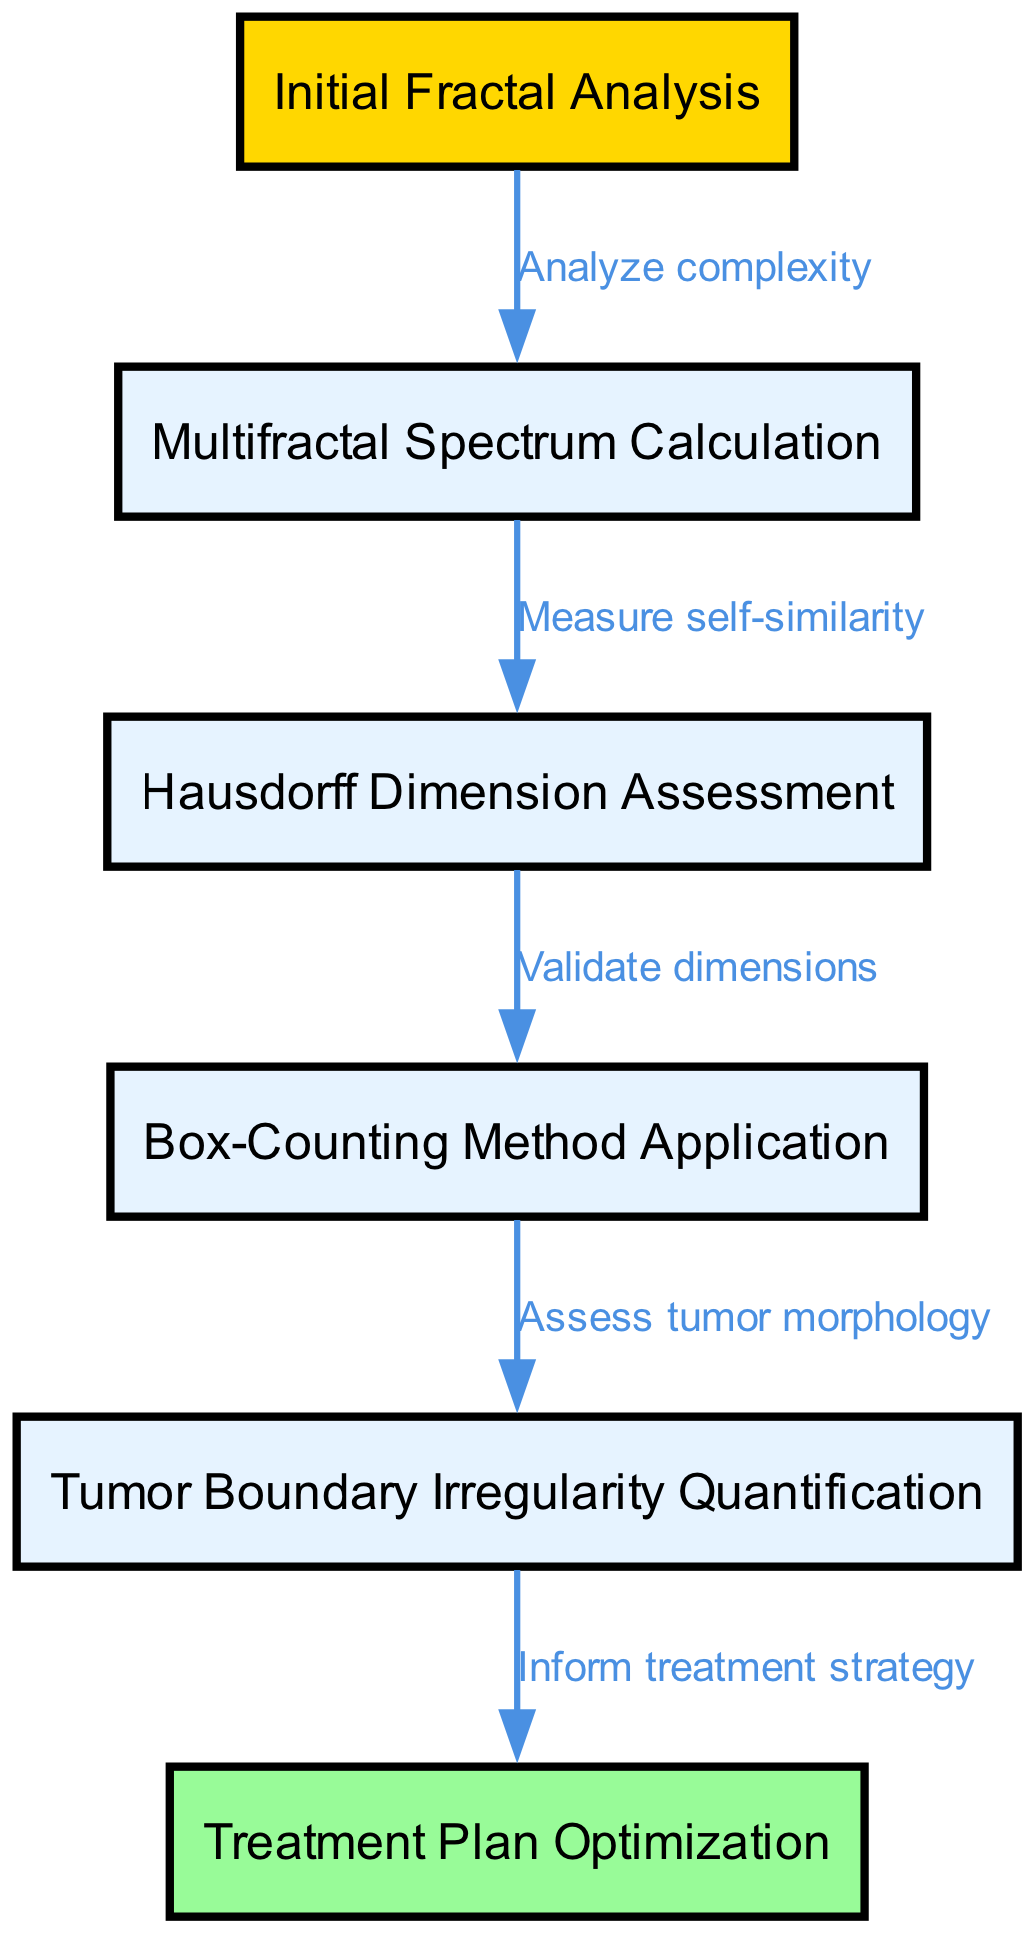What is the first step in the clinical pathway? The first node in the diagram is labeled "Initial Fractal Analysis", which represents the starting point of the clinical pathway.
Answer: Initial Fractal Analysis How many nodes are there in total? By counting all the unique nodes listed, we find there are six different nodes in the diagram.
Answer: 6 Which node assesses tumor morphology? The node that assesses tumor morphology is labeled "Tumor Boundary Irregularity Quantification", as shown in the diagram.
Answer: Tumor Boundary Irregularity Quantification What is the relationship between "Box-Counting Method Application" and "Hausdorff Dimension Assessment"? The directed edge from "Hausdorff Dimension Assessment" to "Box-Counting Method Application" indicates that the Hausdorff Dimension Assessment validates dimensions related to the box-counting application.
Answer: Validate dimensions What is the last step in the clinical pathway? The last node, which signifies the conclusion of the clinical pathway, is labeled "Treatment Plan Optimization".
Answer: Treatment Plan Optimization What kind of analysis is performed after the initial fractal analysis? Following the "Initial Fractal Analysis", the next analysis performed is the "Multifractal Spectrum Calculation", based on the directed flow of the diagram.
Answer: Multifractal Spectrum Calculation Which node informs the treatment strategy? The node that informs the treatment strategy is "Treatment Plan Optimization", as indicated in the latter part of the pathway flow.
Answer: Treatment Plan Optimization What type of dimension is validated in the pathway? The diagram indicates that the "Hausdorff Dimension" is assessed and validated, signifying a specific type of geometric dimension used in fractal geometry.
Answer: Hausdorff Dimension What action comes after quantifying tumor boundary irregularity? The next action taken after quantifying tumor boundary irregularity is to "Inform treatment strategy", as per the edges connecting these nodes in the clinical pathway.
Answer: Inform treatment strategy 